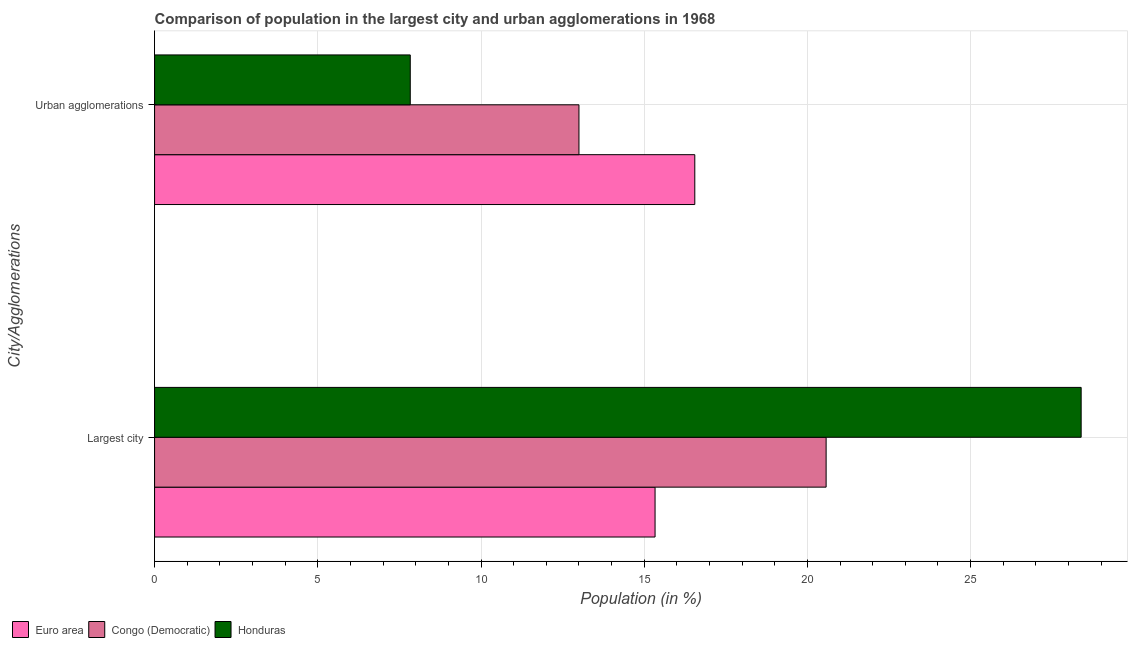How many groups of bars are there?
Provide a succinct answer. 2. How many bars are there on the 2nd tick from the top?
Give a very brief answer. 3. How many bars are there on the 1st tick from the bottom?
Your response must be concise. 3. What is the label of the 2nd group of bars from the top?
Your answer should be very brief. Largest city. What is the population in urban agglomerations in Euro area?
Make the answer very short. 16.55. Across all countries, what is the maximum population in the largest city?
Keep it short and to the point. 28.39. Across all countries, what is the minimum population in urban agglomerations?
Your response must be concise. 7.83. In which country was the population in the largest city minimum?
Provide a short and direct response. Euro area. What is the total population in the largest city in the graph?
Your answer should be compact. 64.29. What is the difference between the population in urban agglomerations in Euro area and that in Congo (Democratic)?
Your answer should be compact. 3.55. What is the difference between the population in the largest city in Honduras and the population in urban agglomerations in Congo (Democratic)?
Give a very brief answer. 15.39. What is the average population in urban agglomerations per country?
Ensure brevity in your answer.  12.46. What is the difference between the population in the largest city and population in urban agglomerations in Honduras?
Provide a short and direct response. 20.55. What is the ratio of the population in the largest city in Euro area to that in Honduras?
Provide a succinct answer. 0.54. Is the population in the largest city in Euro area less than that in Congo (Democratic)?
Provide a short and direct response. Yes. What does the 2nd bar from the top in Urban agglomerations represents?
Give a very brief answer. Congo (Democratic). What does the 1st bar from the bottom in Urban agglomerations represents?
Make the answer very short. Euro area. How many bars are there?
Your answer should be very brief. 6. What is the difference between two consecutive major ticks on the X-axis?
Your answer should be very brief. 5. Are the values on the major ticks of X-axis written in scientific E-notation?
Ensure brevity in your answer.  No. How are the legend labels stacked?
Your answer should be very brief. Horizontal. What is the title of the graph?
Make the answer very short. Comparison of population in the largest city and urban agglomerations in 1968. Does "Turks and Caicos Islands" appear as one of the legend labels in the graph?
Offer a very short reply. No. What is the label or title of the Y-axis?
Your answer should be very brief. City/Agglomerations. What is the Population (in %) in Euro area in Largest city?
Ensure brevity in your answer.  15.33. What is the Population (in %) in Congo (Democratic) in Largest city?
Your answer should be compact. 20.57. What is the Population (in %) of Honduras in Largest city?
Keep it short and to the point. 28.39. What is the Population (in %) in Euro area in Urban agglomerations?
Your answer should be compact. 16.55. What is the Population (in %) of Congo (Democratic) in Urban agglomerations?
Offer a terse response. 13. What is the Population (in %) in Honduras in Urban agglomerations?
Keep it short and to the point. 7.83. Across all City/Agglomerations, what is the maximum Population (in %) in Euro area?
Offer a very short reply. 16.55. Across all City/Agglomerations, what is the maximum Population (in %) of Congo (Democratic)?
Provide a short and direct response. 20.57. Across all City/Agglomerations, what is the maximum Population (in %) of Honduras?
Provide a succinct answer. 28.39. Across all City/Agglomerations, what is the minimum Population (in %) of Euro area?
Give a very brief answer. 15.33. Across all City/Agglomerations, what is the minimum Population (in %) in Congo (Democratic)?
Offer a very short reply. 13. Across all City/Agglomerations, what is the minimum Population (in %) of Honduras?
Your response must be concise. 7.83. What is the total Population (in %) of Euro area in the graph?
Offer a terse response. 31.88. What is the total Population (in %) in Congo (Democratic) in the graph?
Ensure brevity in your answer.  33.57. What is the total Population (in %) of Honduras in the graph?
Give a very brief answer. 36.22. What is the difference between the Population (in %) in Euro area in Largest city and that in Urban agglomerations?
Make the answer very short. -1.22. What is the difference between the Population (in %) in Congo (Democratic) in Largest city and that in Urban agglomerations?
Give a very brief answer. 7.57. What is the difference between the Population (in %) in Honduras in Largest city and that in Urban agglomerations?
Offer a very short reply. 20.55. What is the difference between the Population (in %) of Euro area in Largest city and the Population (in %) of Congo (Democratic) in Urban agglomerations?
Offer a terse response. 2.33. What is the difference between the Population (in %) in Euro area in Largest city and the Population (in %) in Honduras in Urban agglomerations?
Provide a short and direct response. 7.5. What is the difference between the Population (in %) of Congo (Democratic) in Largest city and the Population (in %) of Honduras in Urban agglomerations?
Your answer should be very brief. 12.74. What is the average Population (in %) in Euro area per City/Agglomerations?
Offer a very short reply. 15.94. What is the average Population (in %) in Congo (Democratic) per City/Agglomerations?
Make the answer very short. 16.79. What is the average Population (in %) of Honduras per City/Agglomerations?
Ensure brevity in your answer.  18.11. What is the difference between the Population (in %) of Euro area and Population (in %) of Congo (Democratic) in Largest city?
Give a very brief answer. -5.24. What is the difference between the Population (in %) in Euro area and Population (in %) in Honduras in Largest city?
Your answer should be very brief. -13.05. What is the difference between the Population (in %) of Congo (Democratic) and Population (in %) of Honduras in Largest city?
Give a very brief answer. -7.81. What is the difference between the Population (in %) in Euro area and Population (in %) in Congo (Democratic) in Urban agglomerations?
Offer a very short reply. 3.55. What is the difference between the Population (in %) of Euro area and Population (in %) of Honduras in Urban agglomerations?
Provide a succinct answer. 8.72. What is the difference between the Population (in %) in Congo (Democratic) and Population (in %) in Honduras in Urban agglomerations?
Your answer should be very brief. 5.17. What is the ratio of the Population (in %) of Euro area in Largest city to that in Urban agglomerations?
Keep it short and to the point. 0.93. What is the ratio of the Population (in %) in Congo (Democratic) in Largest city to that in Urban agglomerations?
Offer a very short reply. 1.58. What is the ratio of the Population (in %) of Honduras in Largest city to that in Urban agglomerations?
Give a very brief answer. 3.62. What is the difference between the highest and the second highest Population (in %) in Euro area?
Your answer should be compact. 1.22. What is the difference between the highest and the second highest Population (in %) in Congo (Democratic)?
Your response must be concise. 7.57. What is the difference between the highest and the second highest Population (in %) in Honduras?
Your answer should be compact. 20.55. What is the difference between the highest and the lowest Population (in %) in Euro area?
Give a very brief answer. 1.22. What is the difference between the highest and the lowest Population (in %) of Congo (Democratic)?
Provide a succinct answer. 7.57. What is the difference between the highest and the lowest Population (in %) in Honduras?
Your answer should be very brief. 20.55. 